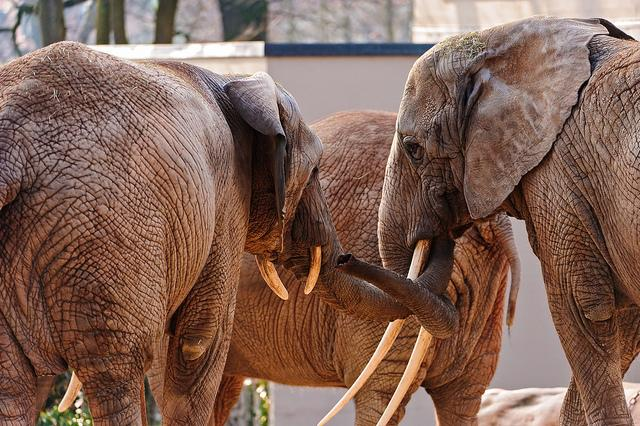How many big elephants are inside of this zoo enclosure together? three 